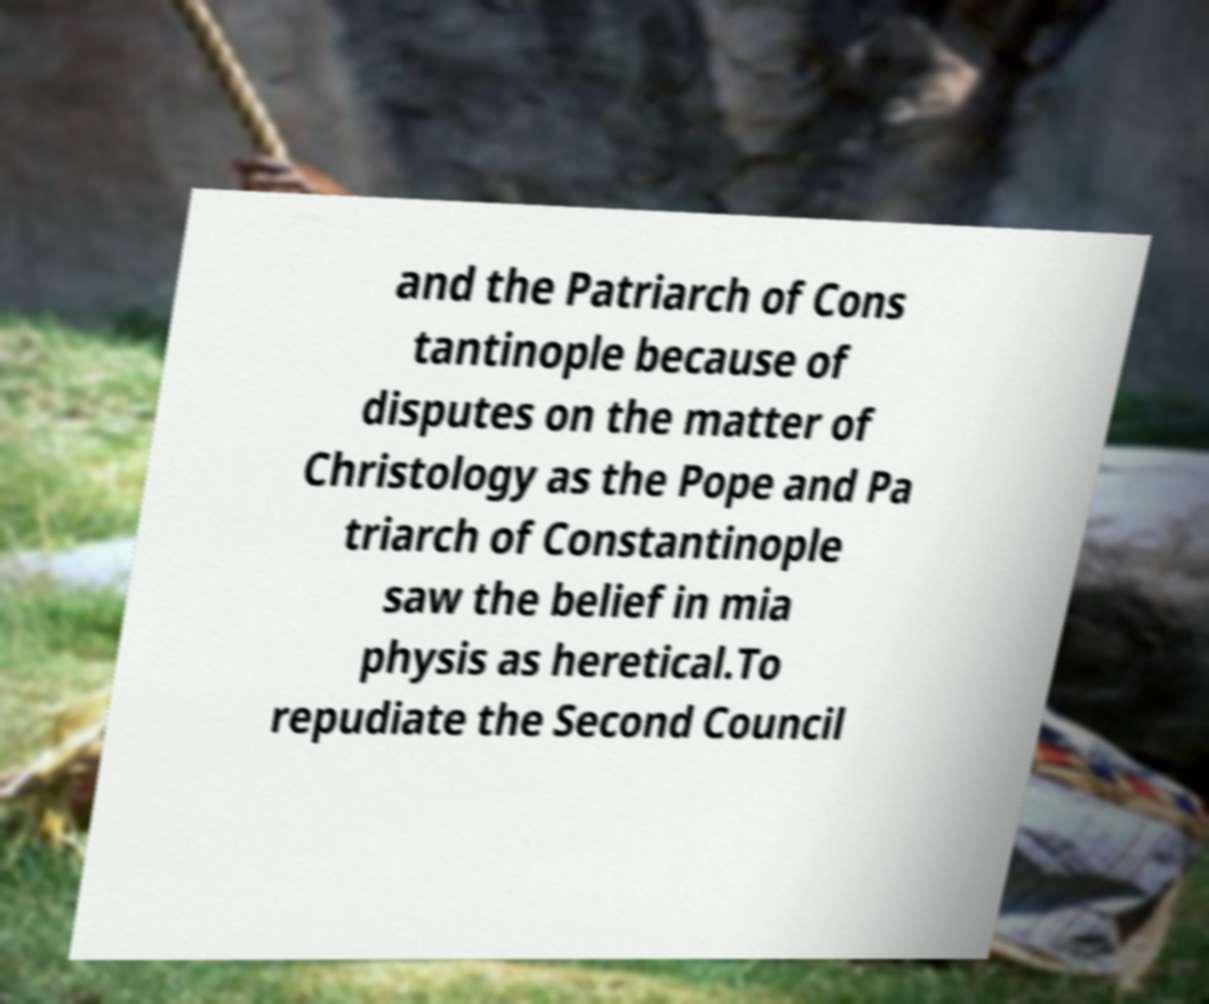Could you assist in decoding the text presented in this image and type it out clearly? and the Patriarch of Cons tantinople because of disputes on the matter of Christology as the Pope and Pa triarch of Constantinople saw the belief in mia physis as heretical.To repudiate the Second Council 